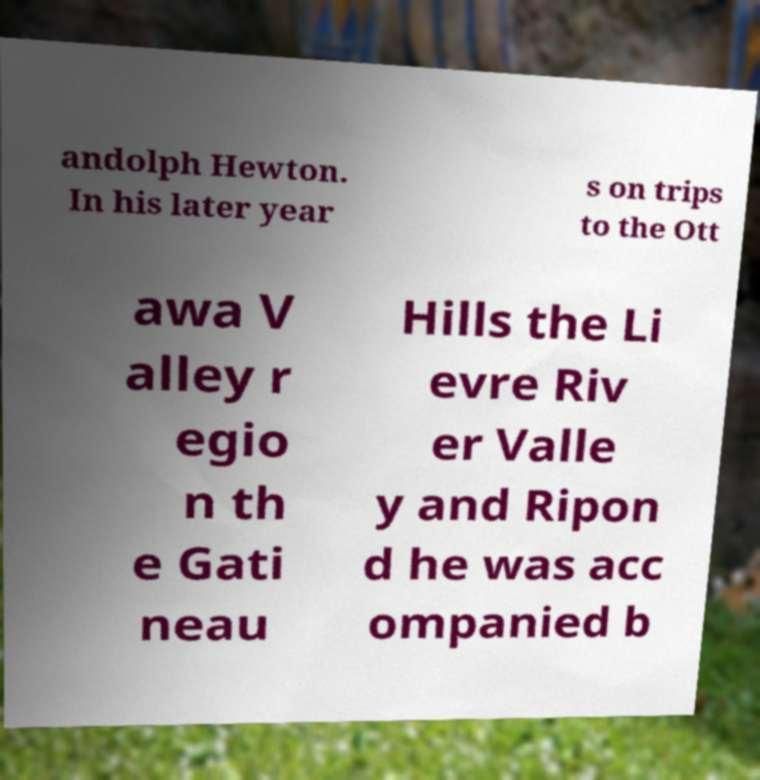Could you assist in decoding the text presented in this image and type it out clearly? andolph Hewton. In his later year s on trips to the Ott awa V alley r egio n th e Gati neau Hills the Li evre Riv er Valle y and Ripon d he was acc ompanied b 